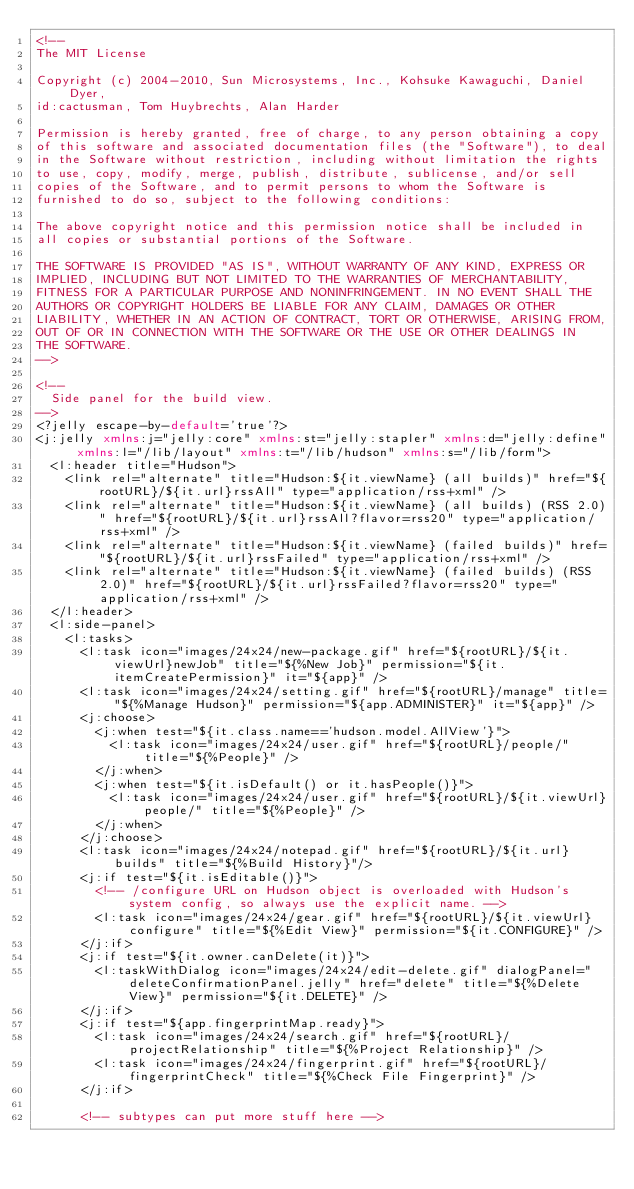<code> <loc_0><loc_0><loc_500><loc_500><_XML_><!--
The MIT License

Copyright (c) 2004-2010, Sun Microsystems, Inc., Kohsuke Kawaguchi, Daniel Dyer,
id:cactusman, Tom Huybrechts, Alan Harder

Permission is hereby granted, free of charge, to any person obtaining a copy
of this software and associated documentation files (the "Software"), to deal
in the Software without restriction, including without limitation the rights
to use, copy, modify, merge, publish, distribute, sublicense, and/or sell
copies of the Software, and to permit persons to whom the Software is
furnished to do so, subject to the following conditions:

The above copyright notice and this permission notice shall be included in
all copies or substantial portions of the Software.

THE SOFTWARE IS PROVIDED "AS IS", WITHOUT WARRANTY OF ANY KIND, EXPRESS OR
IMPLIED, INCLUDING BUT NOT LIMITED TO THE WARRANTIES OF MERCHANTABILITY,
FITNESS FOR A PARTICULAR PURPOSE AND NONINFRINGEMENT. IN NO EVENT SHALL THE
AUTHORS OR COPYRIGHT HOLDERS BE LIABLE FOR ANY CLAIM, DAMAGES OR OTHER
LIABILITY, WHETHER IN AN ACTION OF CONTRACT, TORT OR OTHERWISE, ARISING FROM,
OUT OF OR IN CONNECTION WITH THE SOFTWARE OR THE USE OR OTHER DEALINGS IN
THE SOFTWARE.
-->

<!--
  Side panel for the build view.
-->
<?jelly escape-by-default='true'?>
<j:jelly xmlns:j="jelly:core" xmlns:st="jelly:stapler" xmlns:d="jelly:define" xmlns:l="/lib/layout" xmlns:t="/lib/hudson" xmlns:s="/lib/form">
  <l:header title="Hudson">
    <link rel="alternate" title="Hudson:${it.viewName} (all builds)" href="${rootURL}/${it.url}rssAll" type="application/rss+xml" />
    <link rel="alternate" title="Hudson:${it.viewName} (all builds) (RSS 2.0)" href="${rootURL}/${it.url}rssAll?flavor=rss20" type="application/rss+xml" />
    <link rel="alternate" title="Hudson:${it.viewName} (failed builds)" href="${rootURL}/${it.url}rssFailed" type="application/rss+xml" />
    <link rel="alternate" title="Hudson:${it.viewName} (failed builds) (RSS 2.0)" href="${rootURL}/${it.url}rssFailed?flavor=rss20" type="application/rss+xml" />
  </l:header>
  <l:side-panel>
    <l:tasks>
      <l:task icon="images/24x24/new-package.gif" href="${rootURL}/${it.viewUrl}newJob" title="${%New Job}" permission="${it.itemCreatePermission}" it="${app}" />
      <l:task icon="images/24x24/setting.gif" href="${rootURL}/manage" title="${%Manage Hudson}" permission="${app.ADMINISTER}" it="${app}" />
      <j:choose>
        <j:when test="${it.class.name=='hudson.model.AllView'}">
          <l:task icon="images/24x24/user.gif" href="${rootURL}/people/" title="${%People}" />
        </j:when>
        <j:when test="${it.isDefault() or it.hasPeople()}">
          <l:task icon="images/24x24/user.gif" href="${rootURL}/${it.viewUrl}people/" title="${%People}" />
        </j:when>
      </j:choose>
      <l:task icon="images/24x24/notepad.gif" href="${rootURL}/${it.url}builds" title="${%Build History}"/>
      <j:if test="${it.isEditable()}">
        <!-- /configure URL on Hudson object is overloaded with Hudson's system config, so always use the explicit name. -->
        <l:task icon="images/24x24/gear.gif" href="${rootURL}/${it.viewUrl}configure" title="${%Edit View}" permission="${it.CONFIGURE}" />
      </j:if>
      <j:if test="${it.owner.canDelete(it)}">
        <l:taskWithDialog icon="images/24x24/edit-delete.gif" dialogPanel="deleteConfirmationPanel.jelly" href="delete" title="${%Delete View}" permission="${it.DELETE}" />
      </j:if>
      <j:if test="${app.fingerprintMap.ready}">
        <l:task icon="images/24x24/search.gif" href="${rootURL}/projectRelationship" title="${%Project Relationship}" />
        <l:task icon="images/24x24/fingerprint.gif" href="${rootURL}/fingerprintCheck" title="${%Check File Fingerprint}" />
      </j:if>

      <!-- subtypes can put more stuff here --></code> 